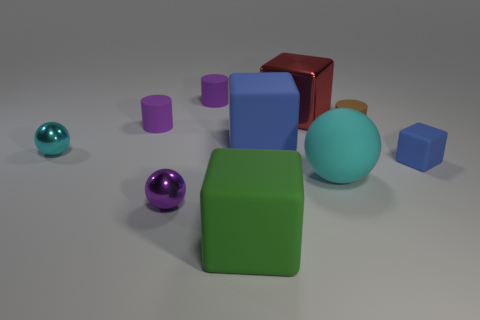The tiny block has what color?
Provide a short and direct response. Blue. What shape is the shiny object in front of the cyan matte thing?
Make the answer very short. Sphere. There is a small cyan thing in front of the large matte block that is behind the small purple shiny ball; are there any large blocks behind it?
Keep it short and to the point. Yes. Is there a metallic cube?
Your answer should be very brief. Yes. Does the tiny cylinder that is to the right of the big shiny block have the same material as the sphere to the left of the small purple metal ball?
Your answer should be very brief. No. What size is the block to the left of the large rubber block that is behind the cube that is in front of the tiny rubber cube?
Your answer should be compact. Large. How many purple objects have the same material as the big blue block?
Offer a terse response. 2. Are there fewer tiny blue objects than big green shiny cylinders?
Give a very brief answer. No. The purple metal object that is the same shape as the tiny cyan object is what size?
Keep it short and to the point. Small. Do the cyan ball to the right of the large green object and the small blue object have the same material?
Provide a succinct answer. Yes. 